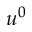Convert formula to latex. <formula><loc_0><loc_0><loc_500><loc_500>u ^ { 0 }</formula> 